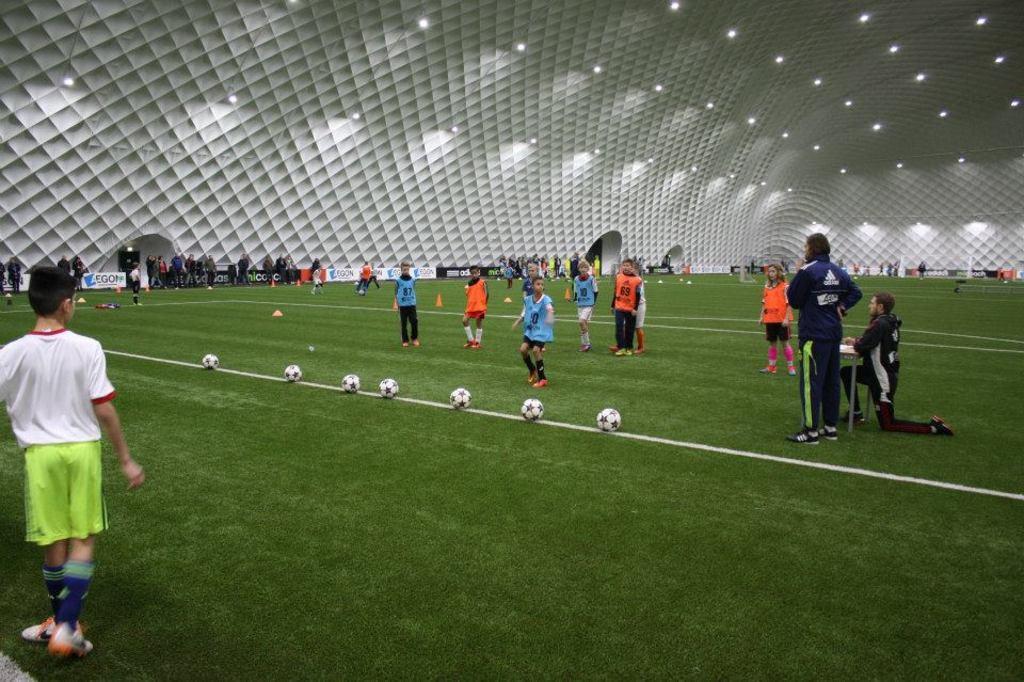Can you describe this image briefly? In this image we can see a group of people playing football, in front of them there are some footballs on the ground, on the right side of the image we can see a man kneeling down in front of a table, in the the background thee are posters with some text and there are some people standing behind it, there are lights to the roof. 